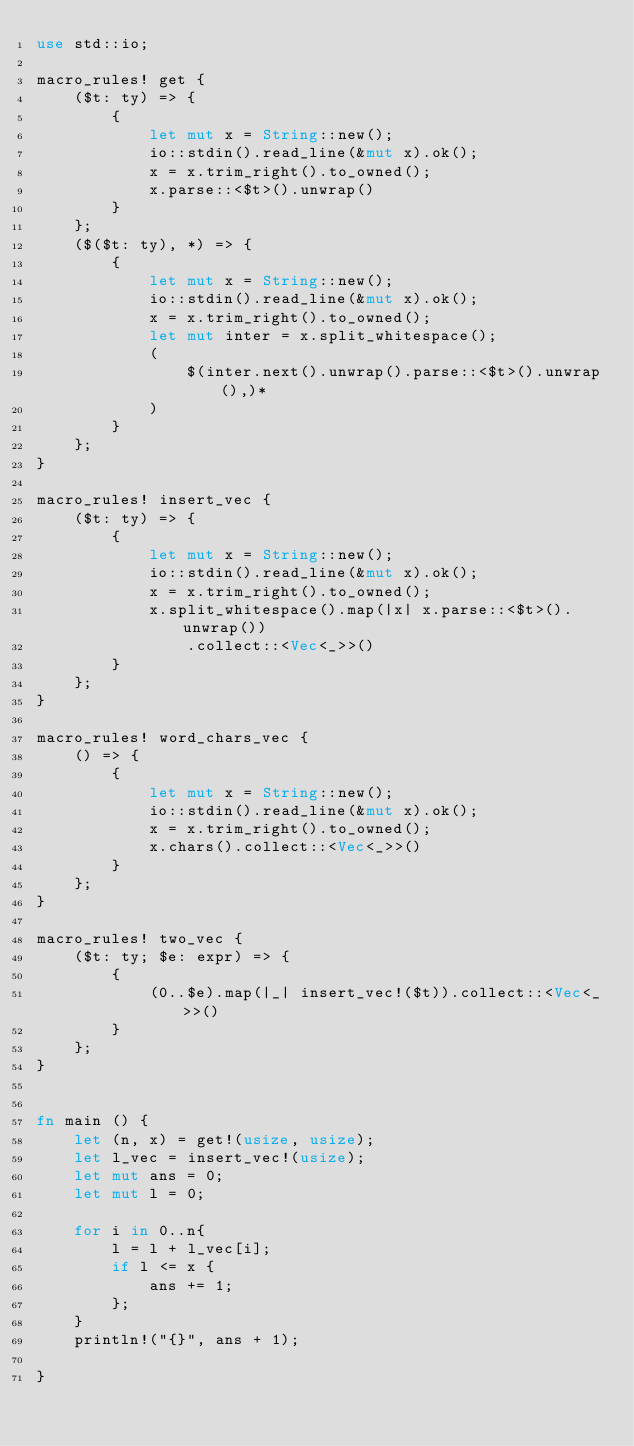<code> <loc_0><loc_0><loc_500><loc_500><_Rust_>use std::io;

macro_rules! get {
    ($t: ty) => {
        {
            let mut x = String::new();
            io::stdin().read_line(&mut x).ok();
            x = x.trim_right().to_owned();
            x.parse::<$t>().unwrap()
        }
    };
    ($($t: ty), *) => {
        {
            let mut x = String::new();
            io::stdin().read_line(&mut x).ok();
            x = x.trim_right().to_owned();
            let mut inter = x.split_whitespace();
            (
                $(inter.next().unwrap().parse::<$t>().unwrap(),)*
            )
        }
    };
}

macro_rules! insert_vec {
    ($t: ty) => {
        {
            let mut x = String::new();
            io::stdin().read_line(&mut x).ok();
            x = x.trim_right().to_owned();
            x.split_whitespace().map(|x| x.parse::<$t>().unwrap())
                .collect::<Vec<_>>()
        }
    };
}

macro_rules! word_chars_vec {
    () => {
        {
            let mut x = String::new();
            io::stdin().read_line(&mut x).ok();
            x = x.trim_right().to_owned();
            x.chars().collect::<Vec<_>>()
        }        
    };
}

macro_rules! two_vec {
    ($t: ty; $e: expr) => {
        {
            (0..$e).map(|_| insert_vec!($t)).collect::<Vec<_>>()
        }
    };
}


fn main () {
    let (n, x) = get!(usize, usize);
    let l_vec = insert_vec!(usize);
    let mut ans = 0;
    let mut l = 0;

    for i in 0..n{
        l = l + l_vec[i];
        if l <= x {
            ans += 1;
        };
    }
    println!("{}", ans + 1);

}
</code> 